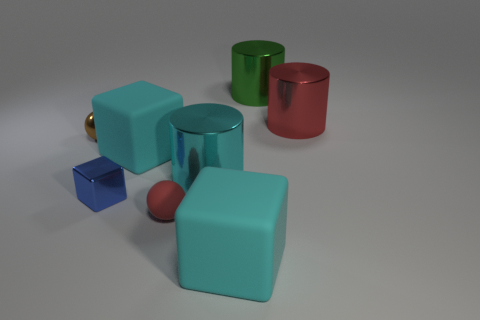What number of metallic objects are either tiny objects or red things?
Keep it short and to the point. 3. The big block that is on the left side of the big rubber block to the right of the small red thing is made of what material?
Give a very brief answer. Rubber. Are there more balls that are on the left side of the small rubber object than big brown spheres?
Offer a very short reply. Yes. Is there a blue block that has the same material as the tiny brown thing?
Give a very brief answer. Yes. There is a large object behind the red metal cylinder; is its shape the same as the small matte thing?
Your response must be concise. No. How many red rubber balls are behind the big metal object that is behind the red thing right of the green metal cylinder?
Offer a very short reply. 0. Are there fewer metallic balls that are in front of the brown thing than large cyan rubber things left of the red rubber object?
Give a very brief answer. Yes. There is a metal thing that is the same shape as the small matte object; what is its color?
Keep it short and to the point. Brown. What is the size of the red matte ball?
Ensure brevity in your answer.  Small. How many gray rubber balls have the same size as the green thing?
Offer a very short reply. 0. 